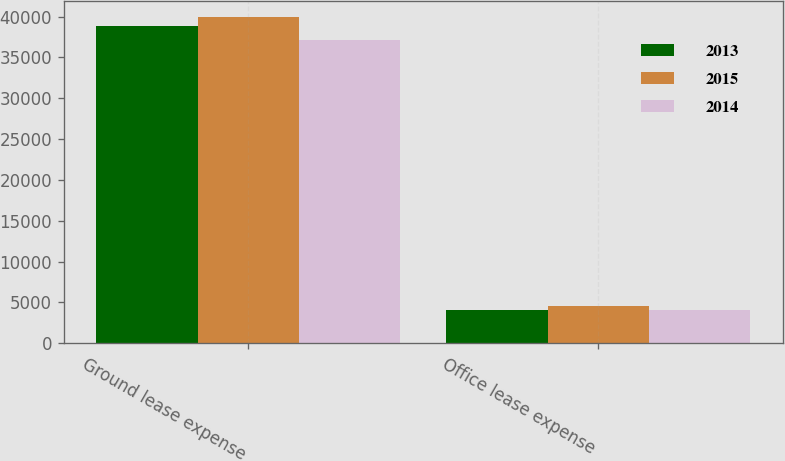Convert chart to OTSL. <chart><loc_0><loc_0><loc_500><loc_500><stacked_bar_chart><ecel><fcel>Ground lease expense<fcel>Office lease expense<nl><fcel>2013<fcel>38851<fcel>4067<nl><fcel>2015<fcel>39898<fcel>4577<nl><fcel>2014<fcel>37150<fcel>4057<nl></chart> 